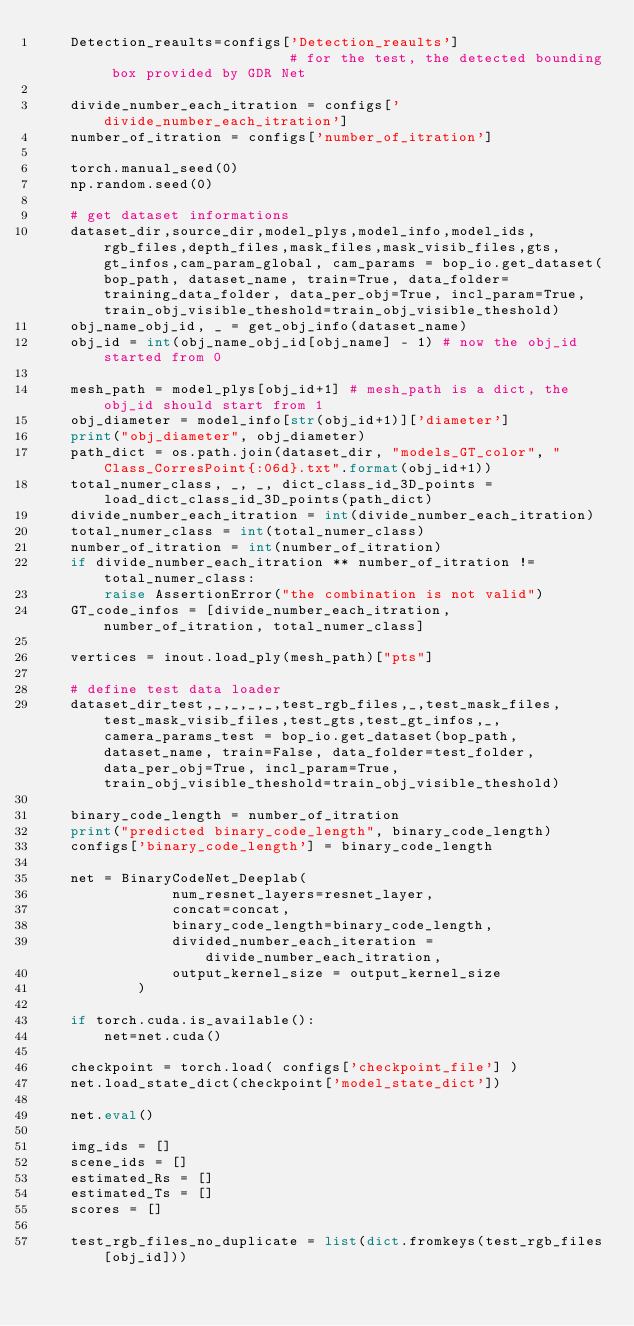<code> <loc_0><loc_0><loc_500><loc_500><_Python_>    Detection_reaults=configs['Detection_reaults']                       # for the test, the detected bounding box provided by GDR Net

    divide_number_each_itration = configs['divide_number_each_itration']
    number_of_itration = configs['number_of_itration']

    torch.manual_seed(0)     
    np.random.seed(0)      

    # get dataset informations
    dataset_dir,source_dir,model_plys,model_info,model_ids,rgb_files,depth_files,mask_files,mask_visib_files,gts,gt_infos,cam_param_global, cam_params = bop_io.get_dataset(bop_path, dataset_name, train=True, data_folder=training_data_folder, data_per_obj=True, incl_param=True, train_obj_visible_theshold=train_obj_visible_theshold)
    obj_name_obj_id, _ = get_obj_info(dataset_name)
    obj_id = int(obj_name_obj_id[obj_name] - 1) # now the obj_id started from 0
    
    mesh_path = model_plys[obj_id+1] # mesh_path is a dict, the obj_id should start from 1
    obj_diameter = model_info[str(obj_id+1)]['diameter']
    print("obj_diameter", obj_diameter)
    path_dict = os.path.join(dataset_dir, "models_GT_color", "Class_CorresPoint{:06d}.txt".format(obj_id+1))
    total_numer_class, _, _, dict_class_id_3D_points = load_dict_class_id_3D_points(path_dict)
    divide_number_each_itration = int(divide_number_each_itration)
    total_numer_class = int(total_numer_class)
    number_of_itration = int(number_of_itration)
    if divide_number_each_itration ** number_of_itration != total_numer_class:
        raise AssertionError("the combination is not valid")
    GT_code_infos = [divide_number_each_itration, number_of_itration, total_numer_class]

    vertices = inout.load_ply(mesh_path)["pts"]

    # define test data loader
    dataset_dir_test,_,_,_,_,test_rgb_files,_,test_mask_files,test_mask_visib_files,test_gts,test_gt_infos,_, camera_params_test = bop_io.get_dataset(bop_path, dataset_name, train=False, data_folder=test_folder, data_per_obj=True, incl_param=True, train_obj_visible_theshold=train_obj_visible_theshold)
      
    binary_code_length = number_of_itration
    print("predicted binary_code_length", binary_code_length)
    configs['binary_code_length'] = binary_code_length
   
    net = BinaryCodeNet_Deeplab(
                num_resnet_layers=resnet_layer, 
                concat=concat, 
                binary_code_length=binary_code_length, 
                divided_number_each_iteration = divide_number_each_itration, 
                output_kernel_size = output_kernel_size
            )

    if torch.cuda.is_available():
        net=net.cuda()

    checkpoint = torch.load( configs['checkpoint_file'] )
    net.load_state_dict(checkpoint['model_state_dict'])

    net.eval()
    
    img_ids = []
    scene_ids = []
    estimated_Rs = []
    estimated_Ts = []
    scores = []

    test_rgb_files_no_duplicate = list(dict.fromkeys(test_rgb_files[obj_id]))
</code> 